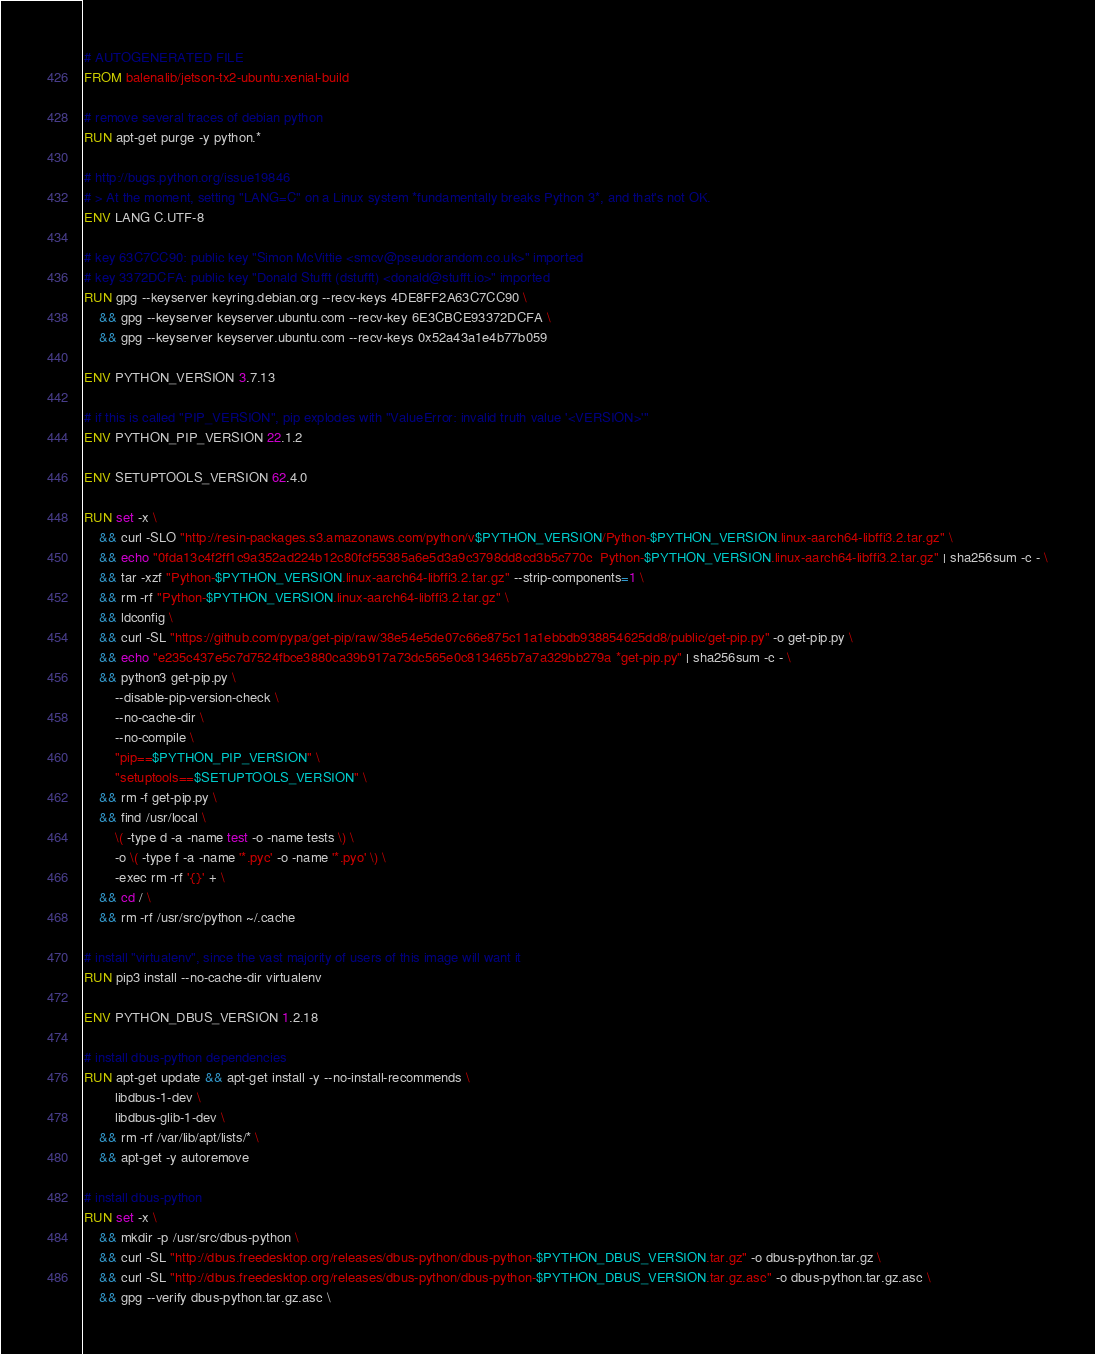Convert code to text. <code><loc_0><loc_0><loc_500><loc_500><_Dockerfile_># AUTOGENERATED FILE
FROM balenalib/jetson-tx2-ubuntu:xenial-build

# remove several traces of debian python
RUN apt-get purge -y python.*

# http://bugs.python.org/issue19846
# > At the moment, setting "LANG=C" on a Linux system *fundamentally breaks Python 3*, and that's not OK.
ENV LANG C.UTF-8

# key 63C7CC90: public key "Simon McVittie <smcv@pseudorandom.co.uk>" imported
# key 3372DCFA: public key "Donald Stufft (dstufft) <donald@stufft.io>" imported
RUN gpg --keyserver keyring.debian.org --recv-keys 4DE8FF2A63C7CC90 \
	&& gpg --keyserver keyserver.ubuntu.com --recv-key 6E3CBCE93372DCFA \
	&& gpg --keyserver keyserver.ubuntu.com --recv-keys 0x52a43a1e4b77b059

ENV PYTHON_VERSION 3.7.13

# if this is called "PIP_VERSION", pip explodes with "ValueError: invalid truth value '<VERSION>'"
ENV PYTHON_PIP_VERSION 22.1.2

ENV SETUPTOOLS_VERSION 62.4.0

RUN set -x \
	&& curl -SLO "http://resin-packages.s3.amazonaws.com/python/v$PYTHON_VERSION/Python-$PYTHON_VERSION.linux-aarch64-libffi3.2.tar.gz" \
	&& echo "0fda13c4f2ff1c9a352ad224b12c80fcf55385a6e5d3a9c3798dd8cd3b5c770c  Python-$PYTHON_VERSION.linux-aarch64-libffi3.2.tar.gz" | sha256sum -c - \
	&& tar -xzf "Python-$PYTHON_VERSION.linux-aarch64-libffi3.2.tar.gz" --strip-components=1 \
	&& rm -rf "Python-$PYTHON_VERSION.linux-aarch64-libffi3.2.tar.gz" \
	&& ldconfig \
	&& curl -SL "https://github.com/pypa/get-pip/raw/38e54e5de07c66e875c11a1ebbdb938854625dd8/public/get-pip.py" -o get-pip.py \
    && echo "e235c437e5c7d7524fbce3880ca39b917a73dc565e0c813465b7a7a329bb279a *get-pip.py" | sha256sum -c - \
    && python3 get-pip.py \
        --disable-pip-version-check \
        --no-cache-dir \
        --no-compile \
        "pip==$PYTHON_PIP_VERSION" \
        "setuptools==$SETUPTOOLS_VERSION" \
	&& rm -f get-pip.py \
	&& find /usr/local \
		\( -type d -a -name test -o -name tests \) \
		-o \( -type f -a -name '*.pyc' -o -name '*.pyo' \) \
		-exec rm -rf '{}' + \
	&& cd / \
	&& rm -rf /usr/src/python ~/.cache

# install "virtualenv", since the vast majority of users of this image will want it
RUN pip3 install --no-cache-dir virtualenv

ENV PYTHON_DBUS_VERSION 1.2.18

# install dbus-python dependencies 
RUN apt-get update && apt-get install -y --no-install-recommends \
		libdbus-1-dev \
		libdbus-glib-1-dev \
	&& rm -rf /var/lib/apt/lists/* \
	&& apt-get -y autoremove

# install dbus-python
RUN set -x \
	&& mkdir -p /usr/src/dbus-python \
	&& curl -SL "http://dbus.freedesktop.org/releases/dbus-python/dbus-python-$PYTHON_DBUS_VERSION.tar.gz" -o dbus-python.tar.gz \
	&& curl -SL "http://dbus.freedesktop.org/releases/dbus-python/dbus-python-$PYTHON_DBUS_VERSION.tar.gz.asc" -o dbus-python.tar.gz.asc \
	&& gpg --verify dbus-python.tar.gz.asc \</code> 